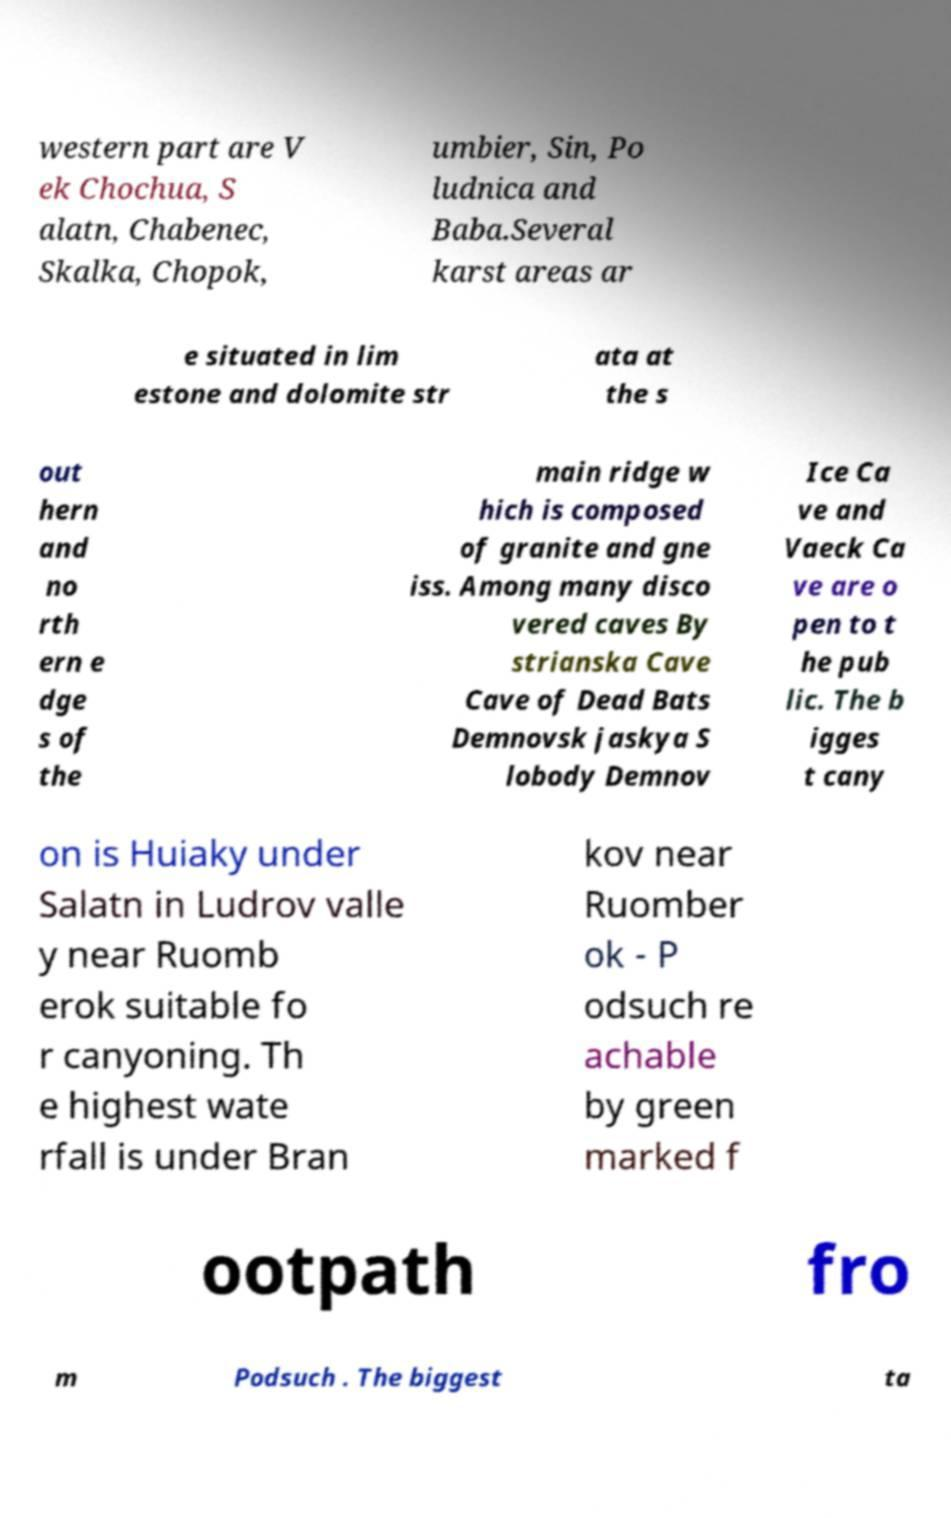What messages or text are displayed in this image? I need them in a readable, typed format. western part are V ek Chochua, S alatn, Chabenec, Skalka, Chopok, umbier, Sin, Po ludnica and Baba.Several karst areas ar e situated in lim estone and dolomite str ata at the s out hern and no rth ern e dge s of the main ridge w hich is composed of granite and gne iss. Among many disco vered caves By strianska Cave Cave of Dead Bats Demnovsk jaskya S lobody Demnov Ice Ca ve and Vaeck Ca ve are o pen to t he pub lic. The b igges t cany on is Huiaky under Salatn in Ludrov valle y near Ruomb erok suitable fo r canyoning. Th e highest wate rfall is under Bran kov near Ruomber ok - P odsuch re achable by green marked f ootpath fro m Podsuch . The biggest ta 